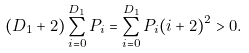<formula> <loc_0><loc_0><loc_500><loc_500>( D _ { 1 } + 2 ) \sum _ { i = 0 } ^ { D _ { 1 } } P _ { i } = \sum _ { i = 0 } ^ { D _ { 1 } } P _ { i } ( i + 2 ) ^ { 2 } > 0 .</formula> 